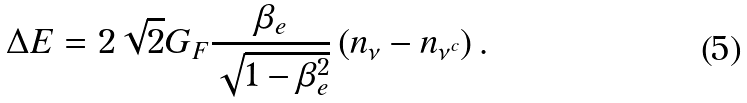<formula> <loc_0><loc_0><loc_500><loc_500>\Delta E = 2 \sqrt { 2 } G _ { F } \frac { \beta _ { e } } { \sqrt { 1 - \beta ^ { 2 } _ { e } } } \left ( n _ { \nu } - n _ { \nu ^ { c } } \right ) .</formula> 